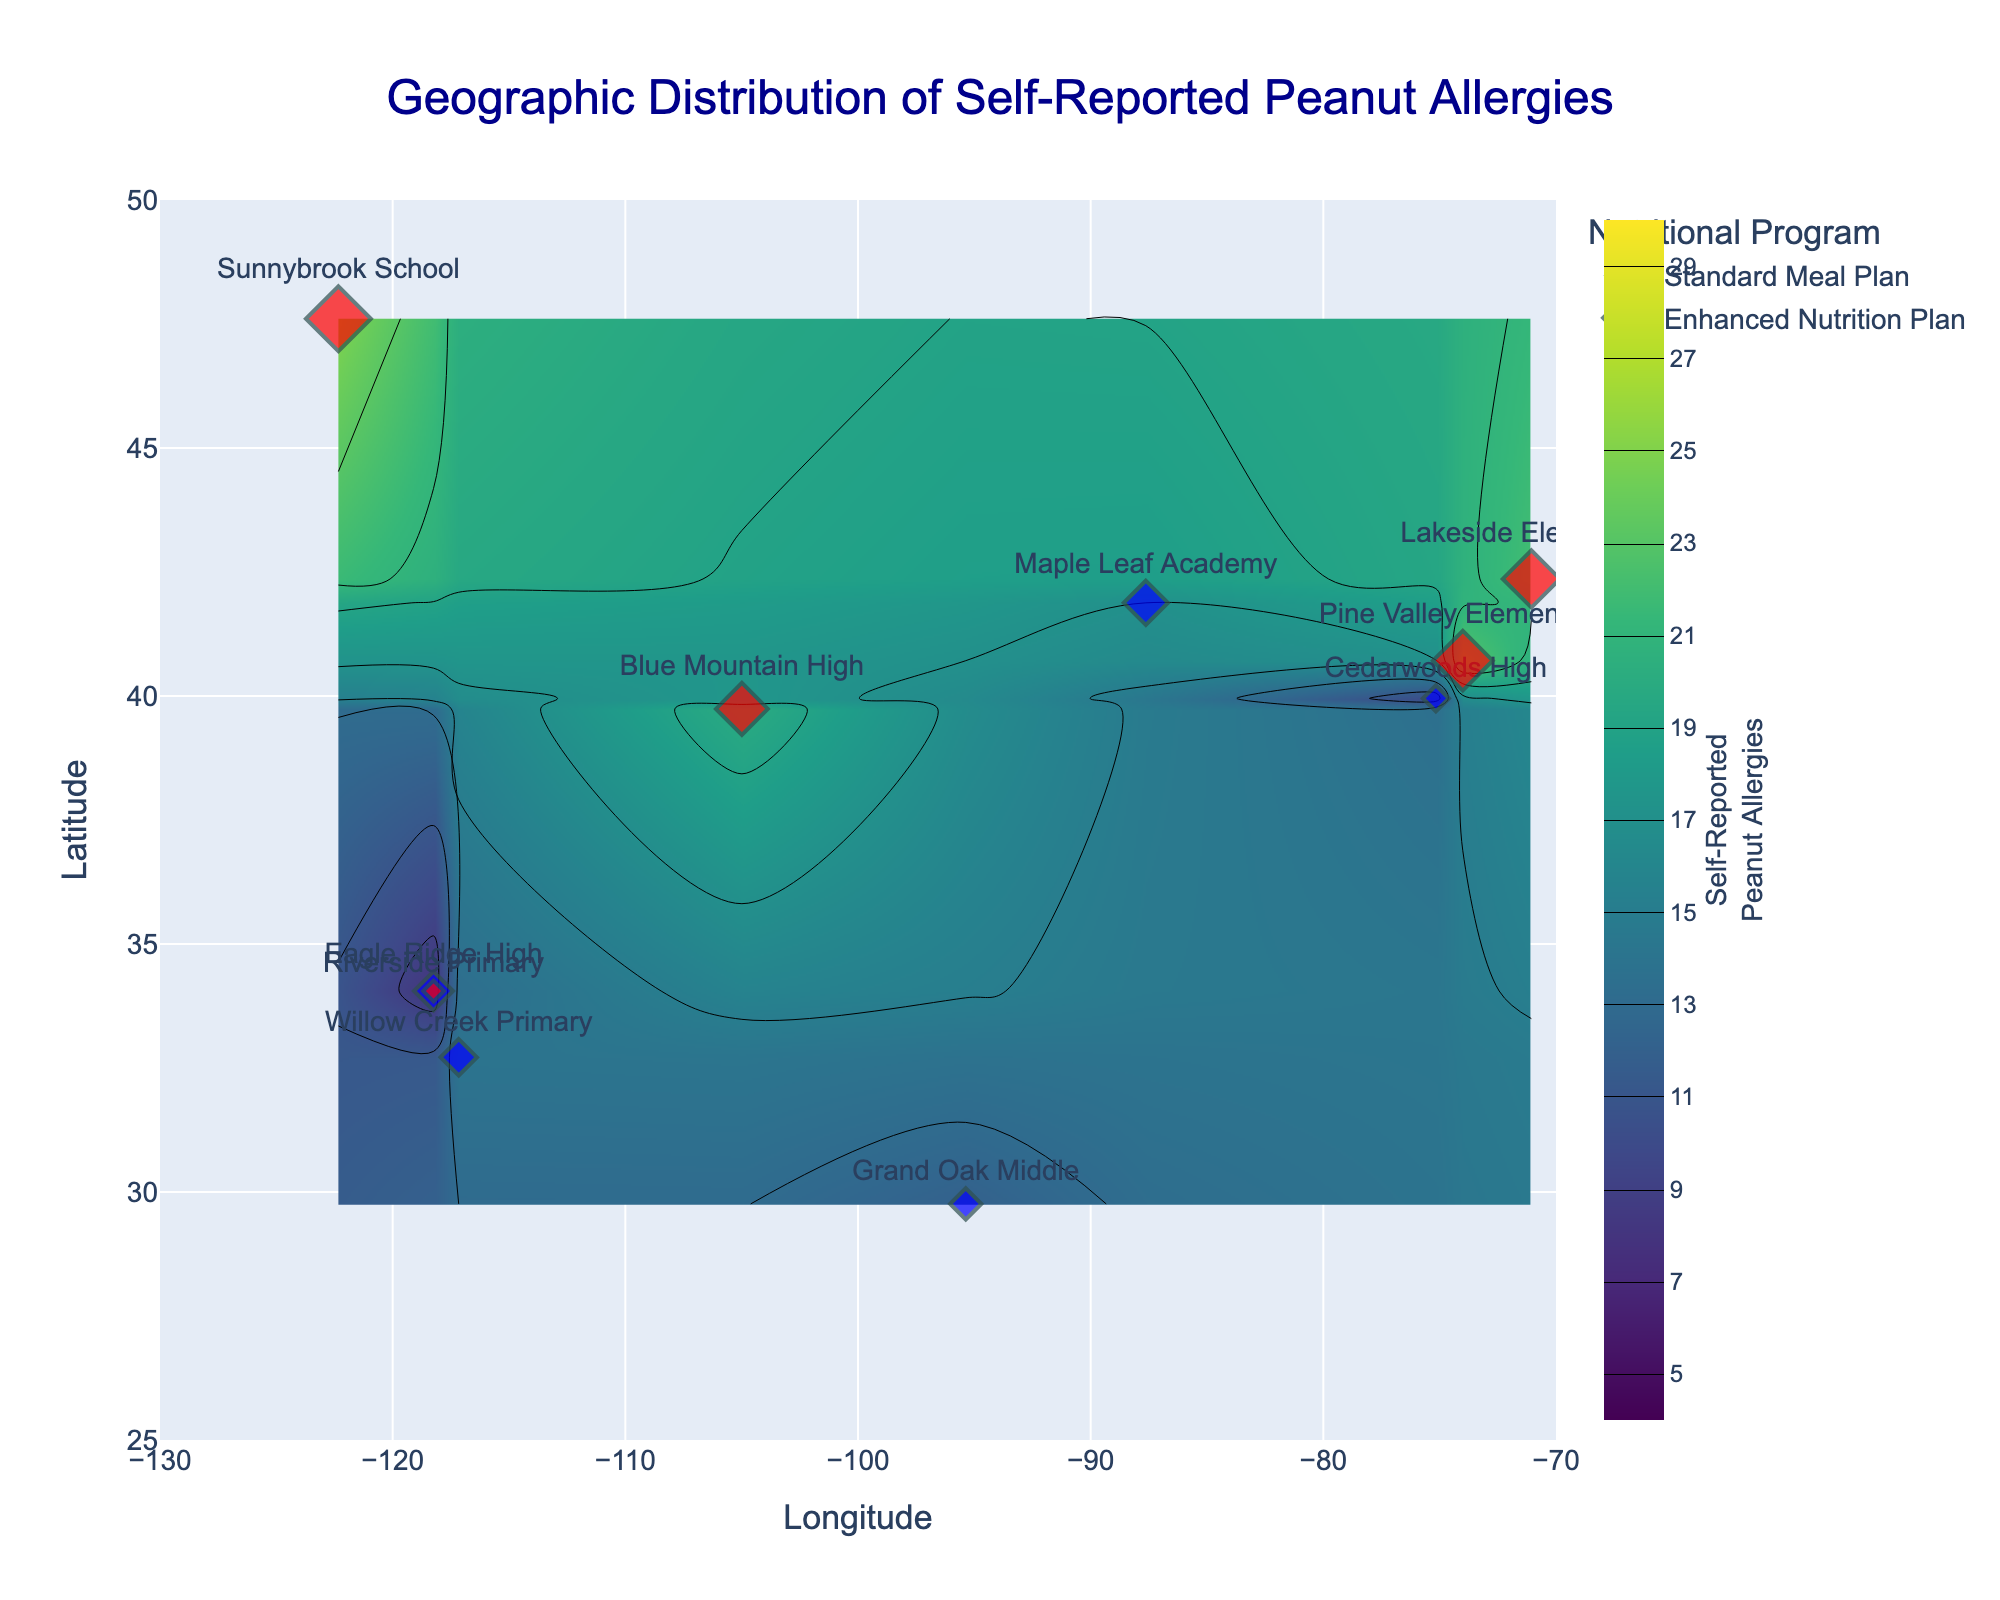What is the title of the plot? The title is typically located at the top of the figure and serves as a description of what the plot represents. In this case, it is clearly shown.
Answer: Geographic Distribution of Self-Reported Peanut Allergies What are the units of the x-axis and y-axis? The units for the axes can be determined by looking at their labels. The x-axis is labeled "Longitude" and the y-axis is labeled "Latitude".
Answer: Longitude, Latitude How many schools are represented in the plot? Each school is indicated by a marker on the scatter plot. There are ten markers, each representing a different school.
Answer: 10 Which nutritional program has a school with the highest number of self-reported peanut allergies? By looking at the size of the markers, the biggest marker corresponds to Sunnybrook School with 25 self-reported peanut allergies, which follows the Enhanced Nutrition Plan.
Answer: Enhanced Nutrition Plan What is the color scheme used to represent different nutritional programs? The color scheme can be discerned by examining the legend in the plot. The Standard Meal Plan is represented by blue markers and the Enhanced Nutrition Plan by red markers.
Answer: Blue and Red Which school has the lowest number of self-reported peanut allergies and what is its nutritional program? Identify the smallest marker on the plot. Riverside Primary has 8 self-reported peanut allergies and follows the Enhanced Nutrition Plan.
Answer: Riverside Primary, Enhanced Nutrition Plan What is the range of self-reported peanut allergies values indicated in the contour plot? The color bar on the right side of the plot indicates the range of values. It starts at 5 and ends at 30.
Answer: 5 to 30 Which school is located at the approximate coordinates (40.7128, -74.0060) and how many self-reported peanut allergies does it have? Locate the point at these coordinates on the plot. Pine Valley Elementary is positioned here with 23 self-reported peanut allergies.
Answer: Pine Valley Elementary, 23 Compare the average number of self-reported peanut allergies between schools with Standard Meal Plan and Enhanced Nutrition Plan. Average for Standard Meal Plan: (15 + 17 + 12 + 14 + 10) / 5 = 13.6. Average for Enhanced Nutrition Plan: (23 + 8 + 20 + 25 + 22) / 5 = 19.6.
Answer: 13.6, 19.6 